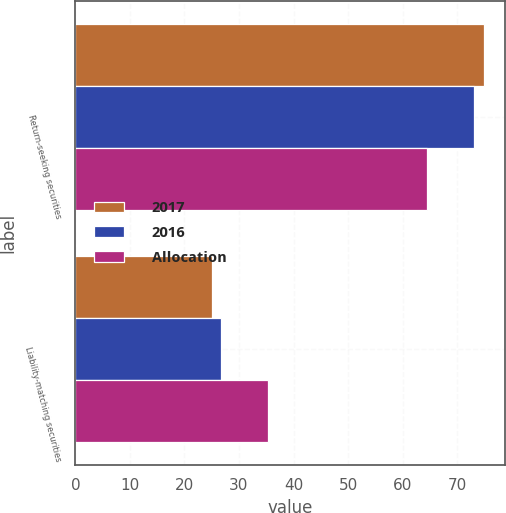<chart> <loc_0><loc_0><loc_500><loc_500><stacked_bar_chart><ecel><fcel>Return-seeking securities<fcel>Liability-matching securities<nl><fcel>2017<fcel>75<fcel>25<nl><fcel>2016<fcel>73.1<fcel>26.7<nl><fcel>Allocation<fcel>64.4<fcel>35.4<nl></chart> 